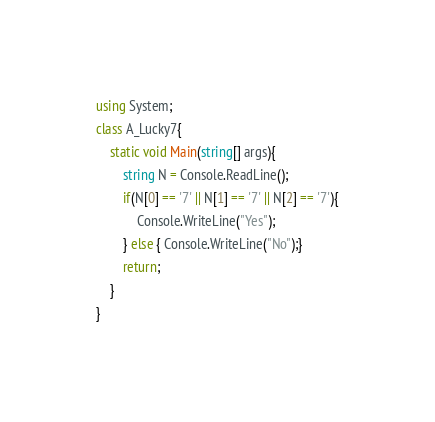Convert code to text. <code><loc_0><loc_0><loc_500><loc_500><_C#_>using System;
class A_Lucky7{
	static void Main(string[] args){
		string N = Console.ReadLine();
		if(N[0] == '7' || N[1] == '7' || N[2] == '7'){
			Console.WriteLine("Yes");
		} else { Console.WriteLine("No");}
		return;
	}
}</code> 